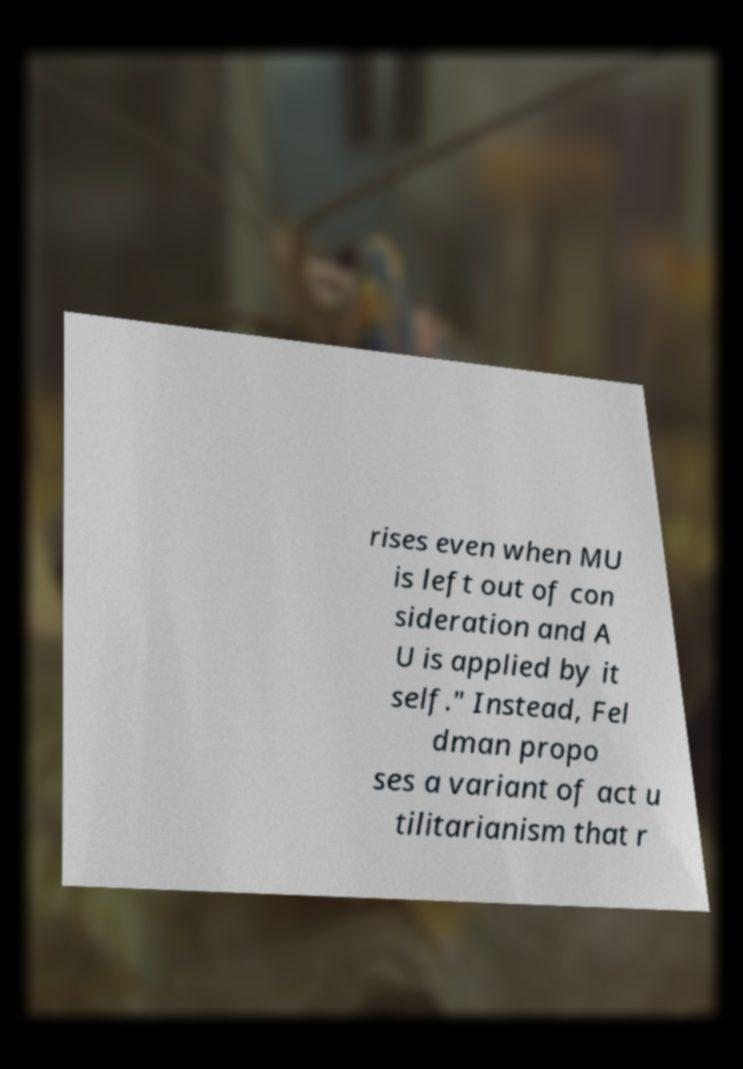I need the written content from this picture converted into text. Can you do that? rises even when MU is left out of con sideration and A U is applied by it self." Instead, Fel dman propo ses a variant of act u tilitarianism that r 